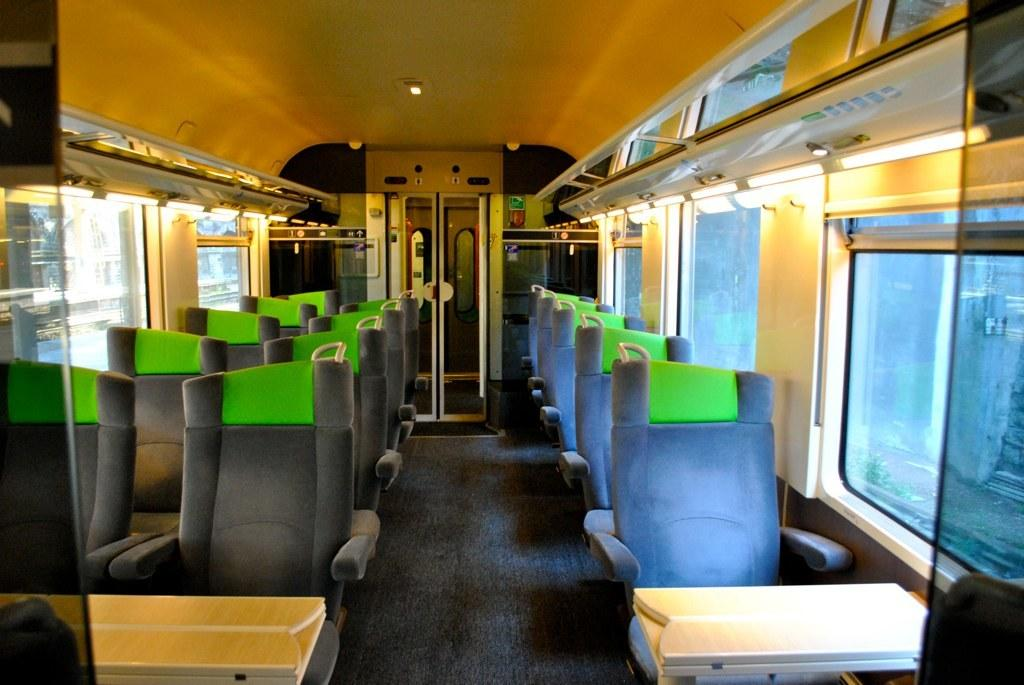What type of vehicle is shown in the image? The image shows the interior of a train. What can be found inside the train? There are seats and lights visible in the image. Are there any doors visible in the image? Yes, there are doors visible in the background. What type of drink is being served to the passengers in the image? There is no drink being served in the image; it only shows the interior of the train. What process is being carried out by the passengers in the image? There is no specific process being carried out by the passengers in the image; they are simply sitting in the train. 